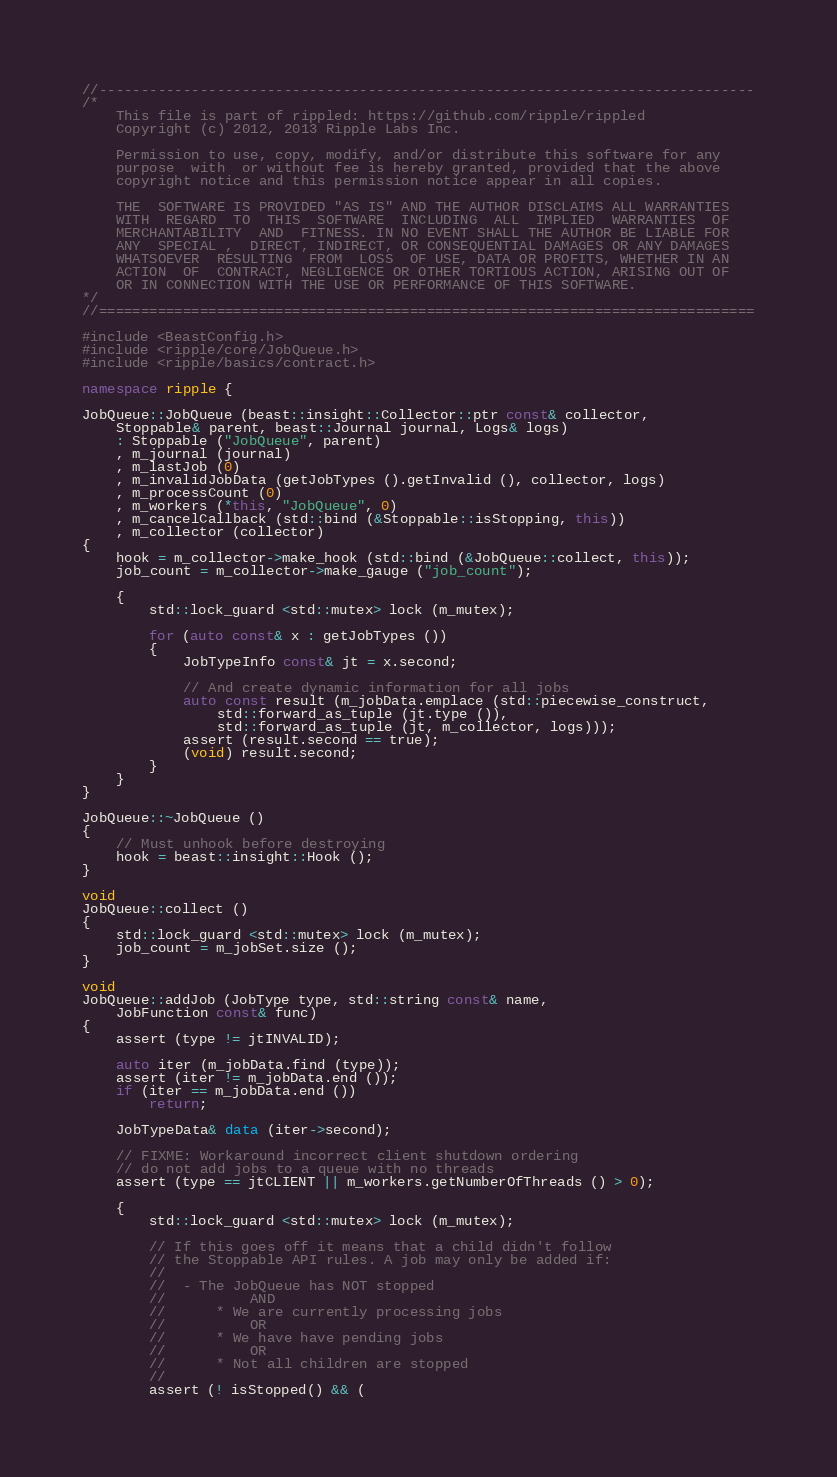Convert code to text. <code><loc_0><loc_0><loc_500><loc_500><_C++_>//------------------------------------------------------------------------------
/*
    This file is part of rippled: https://github.com/ripple/rippled
    Copyright (c) 2012, 2013 Ripple Labs Inc.

    Permission to use, copy, modify, and/or distribute this software for any
    purpose  with  or without fee is hereby granted, provided that the above
    copyright notice and this permission notice appear in all copies.

    THE  SOFTWARE IS PROVIDED "AS IS" AND THE AUTHOR DISCLAIMS ALL WARRANTIES
    WITH  REGARD  TO  THIS  SOFTWARE  INCLUDING  ALL  IMPLIED  WARRANTIES  OF
    MERCHANTABILITY  AND  FITNESS. IN NO EVENT SHALL THE AUTHOR BE LIABLE FOR
    ANY  SPECIAL ,  DIRECT, INDIRECT, OR CONSEQUENTIAL DAMAGES OR ANY DAMAGES
    WHATSOEVER  RESULTING  FROM  LOSS  OF USE, DATA OR PROFITS, WHETHER IN AN
    ACTION  OF  CONTRACT, NEGLIGENCE OR OTHER TORTIOUS ACTION, ARISING OUT OF
    OR IN CONNECTION WITH THE USE OR PERFORMANCE OF THIS SOFTWARE.
*/
//==============================================================================

#include <BeastConfig.h>
#include <ripple/core/JobQueue.h>
#include <ripple/basics/contract.h>

namespace ripple {

JobQueue::JobQueue (beast::insight::Collector::ptr const& collector,
    Stoppable& parent, beast::Journal journal, Logs& logs)
    : Stoppable ("JobQueue", parent)
    , m_journal (journal)
    , m_lastJob (0)
    , m_invalidJobData (getJobTypes ().getInvalid (), collector, logs)
    , m_processCount (0)
    , m_workers (*this, "JobQueue", 0)
    , m_cancelCallback (std::bind (&Stoppable::isStopping, this))
    , m_collector (collector)
{
    hook = m_collector->make_hook (std::bind (&JobQueue::collect, this));
    job_count = m_collector->make_gauge ("job_count");

    {
        std::lock_guard <std::mutex> lock (m_mutex);

        for (auto const& x : getJobTypes ())
        {
            JobTypeInfo const& jt = x.second;

            // And create dynamic information for all jobs
            auto const result (m_jobData.emplace (std::piecewise_construct,
                std::forward_as_tuple (jt.type ()),
                std::forward_as_tuple (jt, m_collector, logs)));
            assert (result.second == true);
            (void) result.second;
        }
    }
}

JobQueue::~JobQueue ()
{
    // Must unhook before destroying
    hook = beast::insight::Hook ();
}

void
JobQueue::collect ()
{
    std::lock_guard <std::mutex> lock (m_mutex);
    job_count = m_jobSet.size ();
}

void
JobQueue::addJob (JobType type, std::string const& name,
    JobFunction const& func)
{
    assert (type != jtINVALID);

    auto iter (m_jobData.find (type));
    assert (iter != m_jobData.end ());
    if (iter == m_jobData.end ())
        return;

    JobTypeData& data (iter->second);

    // FIXME: Workaround incorrect client shutdown ordering
    // do not add jobs to a queue with no threads
    assert (type == jtCLIENT || m_workers.getNumberOfThreads () > 0);

    {
        std::lock_guard <std::mutex> lock (m_mutex);

        // If this goes off it means that a child didn't follow
        // the Stoppable API rules. A job may only be added if:
        //
        //  - The JobQueue has NOT stopped
        //          AND
        //      * We are currently processing jobs
        //          OR
        //      * We have have pending jobs
        //          OR
        //      * Not all children are stopped
        //
        assert (! isStopped() && (</code> 